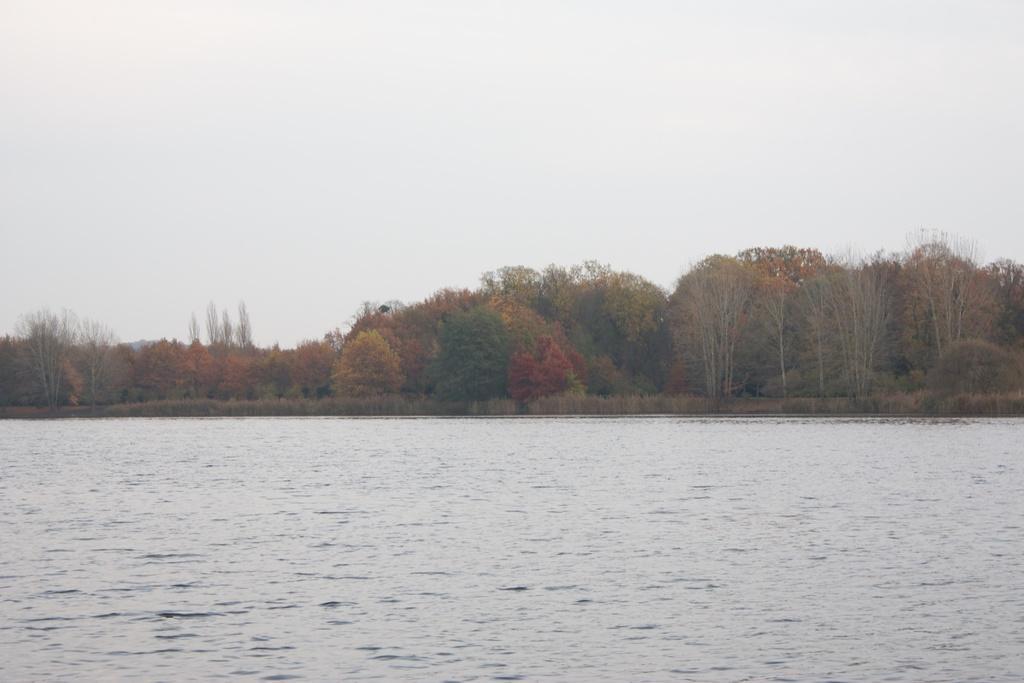Could you give a brief overview of what you see in this image? This image consists of water. In the background, there are trees. At the top, there is sky. 